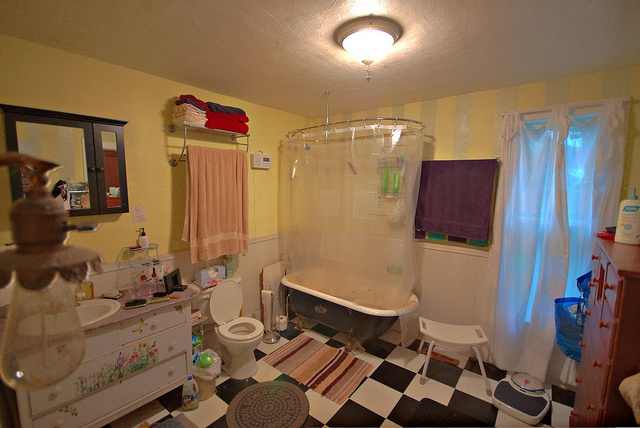Describe the objects in this image and their specific colors. I can see toilet in maroon, tan, gray, and brown tones, chair in maroon, tan, gray, and black tones, sink in maroon, gray, brown, and tan tones, bottle in maroon, gray, tan, and teal tones, and bottle in maroon, gray, tan, and black tones in this image. 